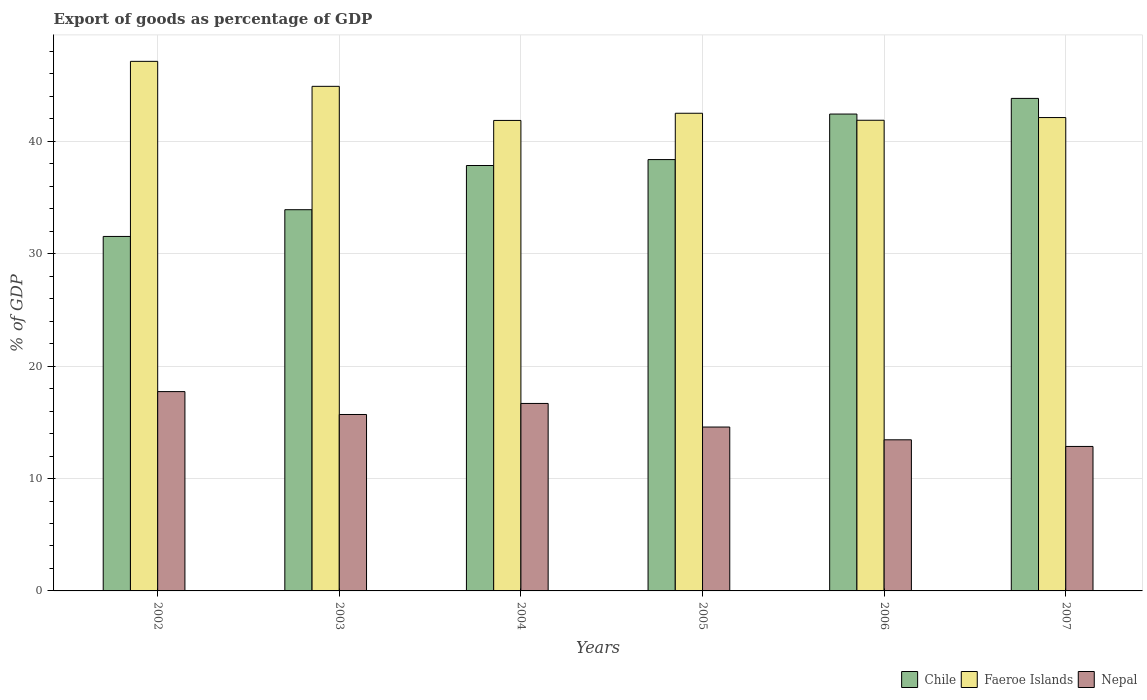How many groups of bars are there?
Ensure brevity in your answer.  6. Are the number of bars on each tick of the X-axis equal?
Provide a short and direct response. Yes. What is the export of goods as percentage of GDP in Chile in 2005?
Provide a succinct answer. 38.38. Across all years, what is the maximum export of goods as percentage of GDP in Chile?
Your response must be concise. 43.83. Across all years, what is the minimum export of goods as percentage of GDP in Faeroe Islands?
Make the answer very short. 41.87. In which year was the export of goods as percentage of GDP in Nepal maximum?
Your answer should be very brief. 2002. In which year was the export of goods as percentage of GDP in Chile minimum?
Offer a terse response. 2002. What is the total export of goods as percentage of GDP in Chile in the graph?
Your answer should be very brief. 227.96. What is the difference between the export of goods as percentage of GDP in Faeroe Islands in 2002 and that in 2004?
Your answer should be compact. 5.26. What is the difference between the export of goods as percentage of GDP in Faeroe Islands in 2007 and the export of goods as percentage of GDP in Nepal in 2002?
Ensure brevity in your answer.  24.39. What is the average export of goods as percentage of GDP in Faeroe Islands per year?
Ensure brevity in your answer.  43.4. In the year 2002, what is the difference between the export of goods as percentage of GDP in Chile and export of goods as percentage of GDP in Faeroe Islands?
Your answer should be compact. -15.58. In how many years, is the export of goods as percentage of GDP in Chile greater than 26 %?
Provide a succinct answer. 6. What is the ratio of the export of goods as percentage of GDP in Nepal in 2002 to that in 2007?
Your answer should be compact. 1.38. Is the export of goods as percentage of GDP in Faeroe Islands in 2002 less than that in 2006?
Your answer should be very brief. No. What is the difference between the highest and the second highest export of goods as percentage of GDP in Chile?
Give a very brief answer. 1.39. What is the difference between the highest and the lowest export of goods as percentage of GDP in Chile?
Keep it short and to the point. 12.28. In how many years, is the export of goods as percentage of GDP in Nepal greater than the average export of goods as percentage of GDP in Nepal taken over all years?
Provide a succinct answer. 3. Is the sum of the export of goods as percentage of GDP in Faeroe Islands in 2002 and 2007 greater than the maximum export of goods as percentage of GDP in Chile across all years?
Your answer should be very brief. Yes. What does the 2nd bar from the left in 2004 represents?
Offer a terse response. Faeroe Islands. What does the 3rd bar from the right in 2004 represents?
Your answer should be compact. Chile. Are the values on the major ticks of Y-axis written in scientific E-notation?
Your response must be concise. No. Does the graph contain any zero values?
Keep it short and to the point. No. Does the graph contain grids?
Your answer should be very brief. Yes. Where does the legend appear in the graph?
Offer a terse response. Bottom right. How many legend labels are there?
Offer a very short reply. 3. What is the title of the graph?
Your response must be concise. Export of goods as percentage of GDP. What is the label or title of the X-axis?
Keep it short and to the point. Years. What is the label or title of the Y-axis?
Your answer should be very brief. % of GDP. What is the % of GDP of Chile in 2002?
Your response must be concise. 31.54. What is the % of GDP in Faeroe Islands in 2002?
Your answer should be very brief. 47.12. What is the % of GDP in Nepal in 2002?
Offer a terse response. 17.74. What is the % of GDP in Chile in 2003?
Offer a terse response. 33.92. What is the % of GDP of Faeroe Islands in 2003?
Ensure brevity in your answer.  44.9. What is the % of GDP in Nepal in 2003?
Give a very brief answer. 15.7. What is the % of GDP of Chile in 2004?
Make the answer very short. 37.86. What is the % of GDP in Faeroe Islands in 2004?
Ensure brevity in your answer.  41.87. What is the % of GDP of Nepal in 2004?
Your answer should be very brief. 16.68. What is the % of GDP in Chile in 2005?
Keep it short and to the point. 38.38. What is the % of GDP of Faeroe Islands in 2005?
Provide a short and direct response. 42.5. What is the % of GDP in Nepal in 2005?
Offer a terse response. 14.58. What is the % of GDP of Chile in 2006?
Offer a terse response. 42.43. What is the % of GDP of Faeroe Islands in 2006?
Provide a short and direct response. 41.88. What is the % of GDP of Nepal in 2006?
Make the answer very short. 13.45. What is the % of GDP in Chile in 2007?
Make the answer very short. 43.83. What is the % of GDP in Faeroe Islands in 2007?
Keep it short and to the point. 42.12. What is the % of GDP of Nepal in 2007?
Make the answer very short. 12.86. Across all years, what is the maximum % of GDP of Chile?
Provide a short and direct response. 43.83. Across all years, what is the maximum % of GDP of Faeroe Islands?
Offer a very short reply. 47.12. Across all years, what is the maximum % of GDP in Nepal?
Provide a succinct answer. 17.74. Across all years, what is the minimum % of GDP in Chile?
Your answer should be very brief. 31.54. Across all years, what is the minimum % of GDP of Faeroe Islands?
Your answer should be compact. 41.87. Across all years, what is the minimum % of GDP in Nepal?
Ensure brevity in your answer.  12.86. What is the total % of GDP in Chile in the graph?
Your answer should be compact. 227.96. What is the total % of GDP of Faeroe Islands in the graph?
Ensure brevity in your answer.  260.4. What is the total % of GDP of Nepal in the graph?
Keep it short and to the point. 91.01. What is the difference between the % of GDP in Chile in 2002 and that in 2003?
Keep it short and to the point. -2.38. What is the difference between the % of GDP in Faeroe Islands in 2002 and that in 2003?
Your answer should be very brief. 2.22. What is the difference between the % of GDP of Nepal in 2002 and that in 2003?
Offer a terse response. 2.04. What is the difference between the % of GDP of Chile in 2002 and that in 2004?
Provide a succinct answer. -6.31. What is the difference between the % of GDP of Faeroe Islands in 2002 and that in 2004?
Offer a terse response. 5.26. What is the difference between the % of GDP of Nepal in 2002 and that in 2004?
Give a very brief answer. 1.05. What is the difference between the % of GDP of Chile in 2002 and that in 2005?
Your answer should be very brief. -6.84. What is the difference between the % of GDP in Faeroe Islands in 2002 and that in 2005?
Your answer should be very brief. 4.62. What is the difference between the % of GDP of Nepal in 2002 and that in 2005?
Your answer should be compact. 3.15. What is the difference between the % of GDP in Chile in 2002 and that in 2006?
Give a very brief answer. -10.89. What is the difference between the % of GDP in Faeroe Islands in 2002 and that in 2006?
Your answer should be very brief. 5.24. What is the difference between the % of GDP of Nepal in 2002 and that in 2006?
Offer a terse response. 4.29. What is the difference between the % of GDP of Chile in 2002 and that in 2007?
Ensure brevity in your answer.  -12.28. What is the difference between the % of GDP in Faeroe Islands in 2002 and that in 2007?
Offer a terse response. 5. What is the difference between the % of GDP of Nepal in 2002 and that in 2007?
Your response must be concise. 4.88. What is the difference between the % of GDP in Chile in 2003 and that in 2004?
Your response must be concise. -3.93. What is the difference between the % of GDP of Faeroe Islands in 2003 and that in 2004?
Your answer should be compact. 3.03. What is the difference between the % of GDP of Nepal in 2003 and that in 2004?
Your answer should be very brief. -0.98. What is the difference between the % of GDP of Chile in 2003 and that in 2005?
Offer a very short reply. -4.46. What is the difference between the % of GDP in Faeroe Islands in 2003 and that in 2005?
Keep it short and to the point. 2.4. What is the difference between the % of GDP of Nepal in 2003 and that in 2005?
Provide a short and direct response. 1.12. What is the difference between the % of GDP of Chile in 2003 and that in 2006?
Ensure brevity in your answer.  -8.51. What is the difference between the % of GDP in Faeroe Islands in 2003 and that in 2006?
Your answer should be very brief. 3.02. What is the difference between the % of GDP in Nepal in 2003 and that in 2006?
Offer a terse response. 2.25. What is the difference between the % of GDP of Chile in 2003 and that in 2007?
Make the answer very short. -9.9. What is the difference between the % of GDP of Faeroe Islands in 2003 and that in 2007?
Ensure brevity in your answer.  2.78. What is the difference between the % of GDP of Nepal in 2003 and that in 2007?
Your answer should be very brief. 2.84. What is the difference between the % of GDP in Chile in 2004 and that in 2005?
Your answer should be compact. -0.53. What is the difference between the % of GDP in Faeroe Islands in 2004 and that in 2005?
Provide a short and direct response. -0.64. What is the difference between the % of GDP of Nepal in 2004 and that in 2005?
Provide a short and direct response. 2.1. What is the difference between the % of GDP of Chile in 2004 and that in 2006?
Your answer should be compact. -4.58. What is the difference between the % of GDP of Faeroe Islands in 2004 and that in 2006?
Offer a very short reply. -0.02. What is the difference between the % of GDP of Nepal in 2004 and that in 2006?
Your response must be concise. 3.24. What is the difference between the % of GDP in Chile in 2004 and that in 2007?
Offer a terse response. -5.97. What is the difference between the % of GDP of Faeroe Islands in 2004 and that in 2007?
Your response must be concise. -0.25. What is the difference between the % of GDP of Nepal in 2004 and that in 2007?
Make the answer very short. 3.83. What is the difference between the % of GDP in Chile in 2005 and that in 2006?
Give a very brief answer. -4.05. What is the difference between the % of GDP in Faeroe Islands in 2005 and that in 2006?
Offer a terse response. 0.62. What is the difference between the % of GDP of Nepal in 2005 and that in 2006?
Ensure brevity in your answer.  1.14. What is the difference between the % of GDP of Chile in 2005 and that in 2007?
Your response must be concise. -5.44. What is the difference between the % of GDP of Faeroe Islands in 2005 and that in 2007?
Ensure brevity in your answer.  0.38. What is the difference between the % of GDP in Nepal in 2005 and that in 2007?
Offer a very short reply. 1.73. What is the difference between the % of GDP of Chile in 2006 and that in 2007?
Make the answer very short. -1.39. What is the difference between the % of GDP of Faeroe Islands in 2006 and that in 2007?
Offer a terse response. -0.24. What is the difference between the % of GDP in Nepal in 2006 and that in 2007?
Your answer should be very brief. 0.59. What is the difference between the % of GDP of Chile in 2002 and the % of GDP of Faeroe Islands in 2003?
Provide a succinct answer. -13.36. What is the difference between the % of GDP of Chile in 2002 and the % of GDP of Nepal in 2003?
Make the answer very short. 15.84. What is the difference between the % of GDP in Faeroe Islands in 2002 and the % of GDP in Nepal in 2003?
Your answer should be compact. 31.42. What is the difference between the % of GDP of Chile in 2002 and the % of GDP of Faeroe Islands in 2004?
Offer a very short reply. -10.32. What is the difference between the % of GDP of Chile in 2002 and the % of GDP of Nepal in 2004?
Keep it short and to the point. 14.86. What is the difference between the % of GDP in Faeroe Islands in 2002 and the % of GDP in Nepal in 2004?
Provide a short and direct response. 30.44. What is the difference between the % of GDP of Chile in 2002 and the % of GDP of Faeroe Islands in 2005?
Make the answer very short. -10.96. What is the difference between the % of GDP in Chile in 2002 and the % of GDP in Nepal in 2005?
Your response must be concise. 16.96. What is the difference between the % of GDP of Faeroe Islands in 2002 and the % of GDP of Nepal in 2005?
Your answer should be very brief. 32.54. What is the difference between the % of GDP in Chile in 2002 and the % of GDP in Faeroe Islands in 2006?
Keep it short and to the point. -10.34. What is the difference between the % of GDP in Chile in 2002 and the % of GDP in Nepal in 2006?
Keep it short and to the point. 18.1. What is the difference between the % of GDP of Faeroe Islands in 2002 and the % of GDP of Nepal in 2006?
Offer a terse response. 33.68. What is the difference between the % of GDP of Chile in 2002 and the % of GDP of Faeroe Islands in 2007?
Offer a very short reply. -10.58. What is the difference between the % of GDP of Chile in 2002 and the % of GDP of Nepal in 2007?
Your answer should be very brief. 18.69. What is the difference between the % of GDP of Faeroe Islands in 2002 and the % of GDP of Nepal in 2007?
Offer a very short reply. 34.27. What is the difference between the % of GDP of Chile in 2003 and the % of GDP of Faeroe Islands in 2004?
Offer a terse response. -7.95. What is the difference between the % of GDP in Chile in 2003 and the % of GDP in Nepal in 2004?
Offer a terse response. 17.24. What is the difference between the % of GDP in Faeroe Islands in 2003 and the % of GDP in Nepal in 2004?
Offer a very short reply. 28.22. What is the difference between the % of GDP of Chile in 2003 and the % of GDP of Faeroe Islands in 2005?
Your response must be concise. -8.58. What is the difference between the % of GDP in Chile in 2003 and the % of GDP in Nepal in 2005?
Offer a terse response. 19.34. What is the difference between the % of GDP of Faeroe Islands in 2003 and the % of GDP of Nepal in 2005?
Provide a short and direct response. 30.32. What is the difference between the % of GDP of Chile in 2003 and the % of GDP of Faeroe Islands in 2006?
Your response must be concise. -7.96. What is the difference between the % of GDP in Chile in 2003 and the % of GDP in Nepal in 2006?
Keep it short and to the point. 20.48. What is the difference between the % of GDP in Faeroe Islands in 2003 and the % of GDP in Nepal in 2006?
Ensure brevity in your answer.  31.45. What is the difference between the % of GDP in Chile in 2003 and the % of GDP in Nepal in 2007?
Provide a short and direct response. 21.07. What is the difference between the % of GDP in Faeroe Islands in 2003 and the % of GDP in Nepal in 2007?
Your answer should be very brief. 32.04. What is the difference between the % of GDP of Chile in 2004 and the % of GDP of Faeroe Islands in 2005?
Your answer should be compact. -4.65. What is the difference between the % of GDP of Chile in 2004 and the % of GDP of Nepal in 2005?
Your answer should be compact. 23.27. What is the difference between the % of GDP in Faeroe Islands in 2004 and the % of GDP in Nepal in 2005?
Ensure brevity in your answer.  27.28. What is the difference between the % of GDP in Chile in 2004 and the % of GDP in Faeroe Islands in 2006?
Your response must be concise. -4.03. What is the difference between the % of GDP in Chile in 2004 and the % of GDP in Nepal in 2006?
Make the answer very short. 24.41. What is the difference between the % of GDP of Faeroe Islands in 2004 and the % of GDP of Nepal in 2006?
Give a very brief answer. 28.42. What is the difference between the % of GDP of Chile in 2004 and the % of GDP of Faeroe Islands in 2007?
Your answer should be very brief. -4.27. What is the difference between the % of GDP of Chile in 2004 and the % of GDP of Nepal in 2007?
Give a very brief answer. 25. What is the difference between the % of GDP of Faeroe Islands in 2004 and the % of GDP of Nepal in 2007?
Your answer should be very brief. 29.01. What is the difference between the % of GDP in Chile in 2005 and the % of GDP in Faeroe Islands in 2006?
Make the answer very short. -3.5. What is the difference between the % of GDP of Chile in 2005 and the % of GDP of Nepal in 2006?
Ensure brevity in your answer.  24.94. What is the difference between the % of GDP of Faeroe Islands in 2005 and the % of GDP of Nepal in 2006?
Offer a terse response. 29.06. What is the difference between the % of GDP of Chile in 2005 and the % of GDP of Faeroe Islands in 2007?
Make the answer very short. -3.74. What is the difference between the % of GDP in Chile in 2005 and the % of GDP in Nepal in 2007?
Provide a short and direct response. 25.53. What is the difference between the % of GDP of Faeroe Islands in 2005 and the % of GDP of Nepal in 2007?
Offer a very short reply. 29.65. What is the difference between the % of GDP in Chile in 2006 and the % of GDP in Faeroe Islands in 2007?
Your answer should be compact. 0.31. What is the difference between the % of GDP of Chile in 2006 and the % of GDP of Nepal in 2007?
Offer a terse response. 29.58. What is the difference between the % of GDP of Faeroe Islands in 2006 and the % of GDP of Nepal in 2007?
Provide a succinct answer. 29.03. What is the average % of GDP of Chile per year?
Ensure brevity in your answer.  37.99. What is the average % of GDP in Faeroe Islands per year?
Your answer should be very brief. 43.4. What is the average % of GDP of Nepal per year?
Ensure brevity in your answer.  15.17. In the year 2002, what is the difference between the % of GDP of Chile and % of GDP of Faeroe Islands?
Provide a succinct answer. -15.58. In the year 2002, what is the difference between the % of GDP in Chile and % of GDP in Nepal?
Give a very brief answer. 13.81. In the year 2002, what is the difference between the % of GDP in Faeroe Islands and % of GDP in Nepal?
Ensure brevity in your answer.  29.39. In the year 2003, what is the difference between the % of GDP in Chile and % of GDP in Faeroe Islands?
Offer a very short reply. -10.98. In the year 2003, what is the difference between the % of GDP of Chile and % of GDP of Nepal?
Your answer should be compact. 18.22. In the year 2003, what is the difference between the % of GDP of Faeroe Islands and % of GDP of Nepal?
Provide a succinct answer. 29.2. In the year 2004, what is the difference between the % of GDP of Chile and % of GDP of Faeroe Islands?
Your answer should be very brief. -4.01. In the year 2004, what is the difference between the % of GDP in Chile and % of GDP in Nepal?
Ensure brevity in your answer.  21.17. In the year 2004, what is the difference between the % of GDP of Faeroe Islands and % of GDP of Nepal?
Offer a terse response. 25.18. In the year 2005, what is the difference between the % of GDP in Chile and % of GDP in Faeroe Islands?
Your response must be concise. -4.12. In the year 2005, what is the difference between the % of GDP in Chile and % of GDP in Nepal?
Your response must be concise. 23.8. In the year 2005, what is the difference between the % of GDP in Faeroe Islands and % of GDP in Nepal?
Provide a succinct answer. 27.92. In the year 2006, what is the difference between the % of GDP in Chile and % of GDP in Faeroe Islands?
Make the answer very short. 0.55. In the year 2006, what is the difference between the % of GDP of Chile and % of GDP of Nepal?
Offer a terse response. 28.99. In the year 2006, what is the difference between the % of GDP of Faeroe Islands and % of GDP of Nepal?
Ensure brevity in your answer.  28.44. In the year 2007, what is the difference between the % of GDP in Chile and % of GDP in Faeroe Islands?
Make the answer very short. 1.7. In the year 2007, what is the difference between the % of GDP in Chile and % of GDP in Nepal?
Make the answer very short. 30.97. In the year 2007, what is the difference between the % of GDP of Faeroe Islands and % of GDP of Nepal?
Make the answer very short. 29.27. What is the ratio of the % of GDP in Chile in 2002 to that in 2003?
Give a very brief answer. 0.93. What is the ratio of the % of GDP in Faeroe Islands in 2002 to that in 2003?
Offer a very short reply. 1.05. What is the ratio of the % of GDP of Nepal in 2002 to that in 2003?
Keep it short and to the point. 1.13. What is the ratio of the % of GDP of Faeroe Islands in 2002 to that in 2004?
Your answer should be compact. 1.13. What is the ratio of the % of GDP of Nepal in 2002 to that in 2004?
Your response must be concise. 1.06. What is the ratio of the % of GDP of Chile in 2002 to that in 2005?
Provide a succinct answer. 0.82. What is the ratio of the % of GDP of Faeroe Islands in 2002 to that in 2005?
Offer a very short reply. 1.11. What is the ratio of the % of GDP of Nepal in 2002 to that in 2005?
Provide a short and direct response. 1.22. What is the ratio of the % of GDP of Chile in 2002 to that in 2006?
Keep it short and to the point. 0.74. What is the ratio of the % of GDP in Faeroe Islands in 2002 to that in 2006?
Offer a terse response. 1.13. What is the ratio of the % of GDP of Nepal in 2002 to that in 2006?
Make the answer very short. 1.32. What is the ratio of the % of GDP of Chile in 2002 to that in 2007?
Keep it short and to the point. 0.72. What is the ratio of the % of GDP in Faeroe Islands in 2002 to that in 2007?
Give a very brief answer. 1.12. What is the ratio of the % of GDP of Nepal in 2002 to that in 2007?
Your answer should be very brief. 1.38. What is the ratio of the % of GDP of Chile in 2003 to that in 2004?
Provide a short and direct response. 0.9. What is the ratio of the % of GDP in Faeroe Islands in 2003 to that in 2004?
Offer a terse response. 1.07. What is the ratio of the % of GDP of Nepal in 2003 to that in 2004?
Ensure brevity in your answer.  0.94. What is the ratio of the % of GDP of Chile in 2003 to that in 2005?
Give a very brief answer. 0.88. What is the ratio of the % of GDP in Faeroe Islands in 2003 to that in 2005?
Keep it short and to the point. 1.06. What is the ratio of the % of GDP of Nepal in 2003 to that in 2005?
Ensure brevity in your answer.  1.08. What is the ratio of the % of GDP of Chile in 2003 to that in 2006?
Provide a succinct answer. 0.8. What is the ratio of the % of GDP of Faeroe Islands in 2003 to that in 2006?
Your answer should be very brief. 1.07. What is the ratio of the % of GDP in Nepal in 2003 to that in 2006?
Offer a terse response. 1.17. What is the ratio of the % of GDP in Chile in 2003 to that in 2007?
Your answer should be very brief. 0.77. What is the ratio of the % of GDP of Faeroe Islands in 2003 to that in 2007?
Provide a short and direct response. 1.07. What is the ratio of the % of GDP in Nepal in 2003 to that in 2007?
Give a very brief answer. 1.22. What is the ratio of the % of GDP in Chile in 2004 to that in 2005?
Ensure brevity in your answer.  0.99. What is the ratio of the % of GDP in Nepal in 2004 to that in 2005?
Offer a very short reply. 1.14. What is the ratio of the % of GDP of Chile in 2004 to that in 2006?
Provide a succinct answer. 0.89. What is the ratio of the % of GDP in Faeroe Islands in 2004 to that in 2006?
Offer a very short reply. 1. What is the ratio of the % of GDP in Nepal in 2004 to that in 2006?
Keep it short and to the point. 1.24. What is the ratio of the % of GDP in Chile in 2004 to that in 2007?
Your response must be concise. 0.86. What is the ratio of the % of GDP of Faeroe Islands in 2004 to that in 2007?
Provide a short and direct response. 0.99. What is the ratio of the % of GDP in Nepal in 2004 to that in 2007?
Your answer should be compact. 1.3. What is the ratio of the % of GDP of Chile in 2005 to that in 2006?
Offer a very short reply. 0.9. What is the ratio of the % of GDP in Faeroe Islands in 2005 to that in 2006?
Offer a terse response. 1.01. What is the ratio of the % of GDP in Nepal in 2005 to that in 2006?
Provide a short and direct response. 1.08. What is the ratio of the % of GDP of Chile in 2005 to that in 2007?
Offer a terse response. 0.88. What is the ratio of the % of GDP in Faeroe Islands in 2005 to that in 2007?
Your response must be concise. 1.01. What is the ratio of the % of GDP in Nepal in 2005 to that in 2007?
Provide a short and direct response. 1.13. What is the ratio of the % of GDP in Chile in 2006 to that in 2007?
Ensure brevity in your answer.  0.97. What is the ratio of the % of GDP of Nepal in 2006 to that in 2007?
Offer a terse response. 1.05. What is the difference between the highest and the second highest % of GDP of Chile?
Make the answer very short. 1.39. What is the difference between the highest and the second highest % of GDP of Faeroe Islands?
Your answer should be compact. 2.22. What is the difference between the highest and the second highest % of GDP in Nepal?
Your answer should be compact. 1.05. What is the difference between the highest and the lowest % of GDP of Chile?
Give a very brief answer. 12.28. What is the difference between the highest and the lowest % of GDP in Faeroe Islands?
Make the answer very short. 5.26. What is the difference between the highest and the lowest % of GDP in Nepal?
Keep it short and to the point. 4.88. 